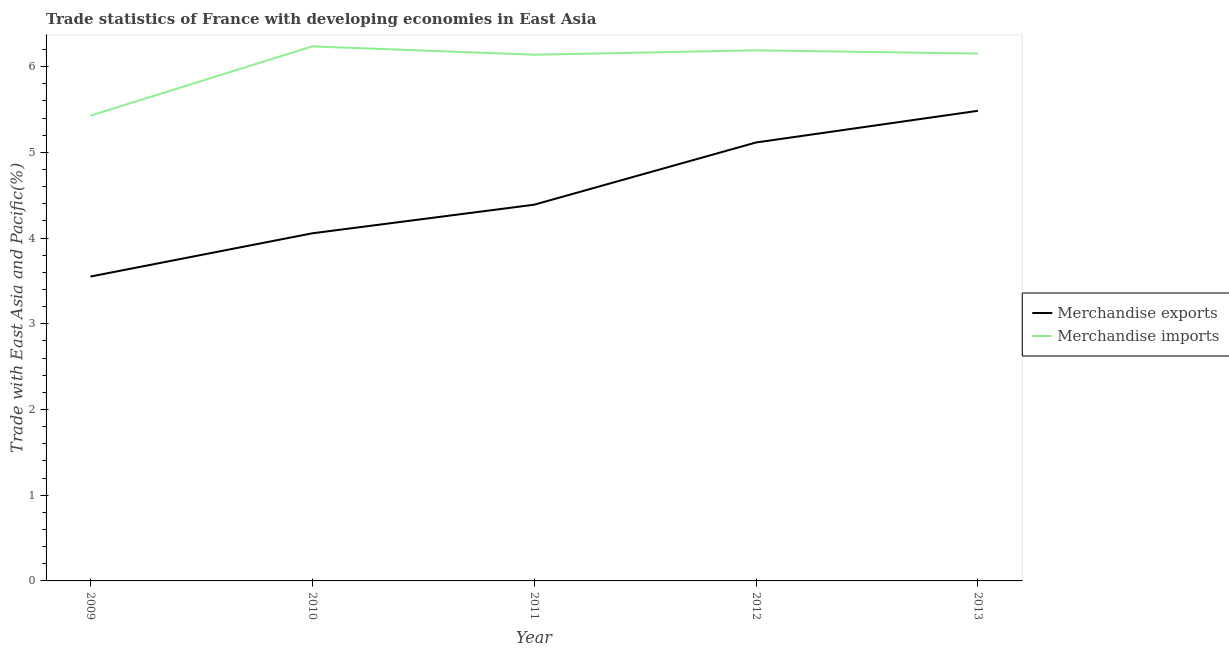How many different coloured lines are there?
Provide a succinct answer. 2. What is the merchandise imports in 2013?
Keep it short and to the point. 6.15. Across all years, what is the maximum merchandise imports?
Offer a very short reply. 6.24. Across all years, what is the minimum merchandise imports?
Make the answer very short. 5.43. In which year was the merchandise exports maximum?
Provide a succinct answer. 2013. In which year was the merchandise exports minimum?
Keep it short and to the point. 2009. What is the total merchandise exports in the graph?
Your answer should be compact. 22.6. What is the difference between the merchandise imports in 2011 and that in 2012?
Ensure brevity in your answer.  -0.05. What is the difference between the merchandise imports in 2013 and the merchandise exports in 2009?
Provide a succinct answer. 2.6. What is the average merchandise imports per year?
Offer a terse response. 6.03. In the year 2011, what is the difference between the merchandise imports and merchandise exports?
Provide a short and direct response. 1.75. In how many years, is the merchandise imports greater than 4.6 %?
Offer a very short reply. 5. What is the ratio of the merchandise exports in 2010 to that in 2013?
Provide a short and direct response. 0.74. What is the difference between the highest and the second highest merchandise imports?
Provide a succinct answer. 0.05. What is the difference between the highest and the lowest merchandise exports?
Your response must be concise. 1.93. Does the merchandise exports monotonically increase over the years?
Your answer should be very brief. Yes. Is the merchandise imports strictly less than the merchandise exports over the years?
Your answer should be very brief. No. How many lines are there?
Give a very brief answer. 2. How many years are there in the graph?
Provide a succinct answer. 5. What is the difference between two consecutive major ticks on the Y-axis?
Make the answer very short. 1. Are the values on the major ticks of Y-axis written in scientific E-notation?
Provide a succinct answer. No. Does the graph contain grids?
Your answer should be very brief. No. How are the legend labels stacked?
Ensure brevity in your answer.  Vertical. What is the title of the graph?
Your answer should be very brief. Trade statistics of France with developing economies in East Asia. What is the label or title of the Y-axis?
Your response must be concise. Trade with East Asia and Pacific(%). What is the Trade with East Asia and Pacific(%) of Merchandise exports in 2009?
Provide a short and direct response. 3.55. What is the Trade with East Asia and Pacific(%) of Merchandise imports in 2009?
Make the answer very short. 5.43. What is the Trade with East Asia and Pacific(%) of Merchandise exports in 2010?
Give a very brief answer. 4.06. What is the Trade with East Asia and Pacific(%) of Merchandise imports in 2010?
Your answer should be compact. 6.24. What is the Trade with East Asia and Pacific(%) in Merchandise exports in 2011?
Your answer should be very brief. 4.39. What is the Trade with East Asia and Pacific(%) in Merchandise imports in 2011?
Ensure brevity in your answer.  6.14. What is the Trade with East Asia and Pacific(%) of Merchandise exports in 2012?
Your answer should be very brief. 5.12. What is the Trade with East Asia and Pacific(%) of Merchandise imports in 2012?
Offer a very short reply. 6.19. What is the Trade with East Asia and Pacific(%) of Merchandise exports in 2013?
Keep it short and to the point. 5.48. What is the Trade with East Asia and Pacific(%) of Merchandise imports in 2013?
Make the answer very short. 6.15. Across all years, what is the maximum Trade with East Asia and Pacific(%) in Merchandise exports?
Keep it short and to the point. 5.48. Across all years, what is the maximum Trade with East Asia and Pacific(%) of Merchandise imports?
Provide a short and direct response. 6.24. Across all years, what is the minimum Trade with East Asia and Pacific(%) in Merchandise exports?
Ensure brevity in your answer.  3.55. Across all years, what is the minimum Trade with East Asia and Pacific(%) in Merchandise imports?
Ensure brevity in your answer.  5.43. What is the total Trade with East Asia and Pacific(%) in Merchandise exports in the graph?
Make the answer very short. 22.6. What is the total Trade with East Asia and Pacific(%) of Merchandise imports in the graph?
Your answer should be very brief. 30.15. What is the difference between the Trade with East Asia and Pacific(%) in Merchandise exports in 2009 and that in 2010?
Provide a succinct answer. -0.5. What is the difference between the Trade with East Asia and Pacific(%) in Merchandise imports in 2009 and that in 2010?
Make the answer very short. -0.81. What is the difference between the Trade with East Asia and Pacific(%) in Merchandise exports in 2009 and that in 2011?
Your answer should be very brief. -0.84. What is the difference between the Trade with East Asia and Pacific(%) of Merchandise imports in 2009 and that in 2011?
Your response must be concise. -0.71. What is the difference between the Trade with East Asia and Pacific(%) of Merchandise exports in 2009 and that in 2012?
Give a very brief answer. -1.56. What is the difference between the Trade with East Asia and Pacific(%) of Merchandise imports in 2009 and that in 2012?
Your answer should be very brief. -0.76. What is the difference between the Trade with East Asia and Pacific(%) of Merchandise exports in 2009 and that in 2013?
Ensure brevity in your answer.  -1.93. What is the difference between the Trade with East Asia and Pacific(%) of Merchandise imports in 2009 and that in 2013?
Ensure brevity in your answer.  -0.72. What is the difference between the Trade with East Asia and Pacific(%) in Merchandise exports in 2010 and that in 2011?
Ensure brevity in your answer.  -0.33. What is the difference between the Trade with East Asia and Pacific(%) of Merchandise imports in 2010 and that in 2011?
Give a very brief answer. 0.1. What is the difference between the Trade with East Asia and Pacific(%) of Merchandise exports in 2010 and that in 2012?
Your response must be concise. -1.06. What is the difference between the Trade with East Asia and Pacific(%) in Merchandise imports in 2010 and that in 2012?
Your answer should be very brief. 0.05. What is the difference between the Trade with East Asia and Pacific(%) of Merchandise exports in 2010 and that in 2013?
Provide a succinct answer. -1.43. What is the difference between the Trade with East Asia and Pacific(%) in Merchandise imports in 2010 and that in 2013?
Your answer should be very brief. 0.08. What is the difference between the Trade with East Asia and Pacific(%) in Merchandise exports in 2011 and that in 2012?
Your answer should be very brief. -0.73. What is the difference between the Trade with East Asia and Pacific(%) of Merchandise imports in 2011 and that in 2012?
Make the answer very short. -0.05. What is the difference between the Trade with East Asia and Pacific(%) in Merchandise exports in 2011 and that in 2013?
Give a very brief answer. -1.1. What is the difference between the Trade with East Asia and Pacific(%) in Merchandise imports in 2011 and that in 2013?
Your answer should be very brief. -0.01. What is the difference between the Trade with East Asia and Pacific(%) in Merchandise exports in 2012 and that in 2013?
Your answer should be compact. -0.37. What is the difference between the Trade with East Asia and Pacific(%) in Merchandise imports in 2012 and that in 2013?
Offer a terse response. 0.04. What is the difference between the Trade with East Asia and Pacific(%) in Merchandise exports in 2009 and the Trade with East Asia and Pacific(%) in Merchandise imports in 2010?
Offer a terse response. -2.69. What is the difference between the Trade with East Asia and Pacific(%) of Merchandise exports in 2009 and the Trade with East Asia and Pacific(%) of Merchandise imports in 2011?
Keep it short and to the point. -2.59. What is the difference between the Trade with East Asia and Pacific(%) in Merchandise exports in 2009 and the Trade with East Asia and Pacific(%) in Merchandise imports in 2012?
Offer a very short reply. -2.64. What is the difference between the Trade with East Asia and Pacific(%) in Merchandise exports in 2009 and the Trade with East Asia and Pacific(%) in Merchandise imports in 2013?
Your answer should be very brief. -2.6. What is the difference between the Trade with East Asia and Pacific(%) in Merchandise exports in 2010 and the Trade with East Asia and Pacific(%) in Merchandise imports in 2011?
Offer a very short reply. -2.08. What is the difference between the Trade with East Asia and Pacific(%) in Merchandise exports in 2010 and the Trade with East Asia and Pacific(%) in Merchandise imports in 2012?
Your answer should be compact. -2.13. What is the difference between the Trade with East Asia and Pacific(%) in Merchandise exports in 2010 and the Trade with East Asia and Pacific(%) in Merchandise imports in 2013?
Your response must be concise. -2.1. What is the difference between the Trade with East Asia and Pacific(%) in Merchandise exports in 2011 and the Trade with East Asia and Pacific(%) in Merchandise imports in 2012?
Your answer should be very brief. -1.8. What is the difference between the Trade with East Asia and Pacific(%) of Merchandise exports in 2011 and the Trade with East Asia and Pacific(%) of Merchandise imports in 2013?
Provide a short and direct response. -1.76. What is the difference between the Trade with East Asia and Pacific(%) in Merchandise exports in 2012 and the Trade with East Asia and Pacific(%) in Merchandise imports in 2013?
Your answer should be compact. -1.04. What is the average Trade with East Asia and Pacific(%) in Merchandise exports per year?
Give a very brief answer. 4.52. What is the average Trade with East Asia and Pacific(%) of Merchandise imports per year?
Your response must be concise. 6.03. In the year 2009, what is the difference between the Trade with East Asia and Pacific(%) of Merchandise exports and Trade with East Asia and Pacific(%) of Merchandise imports?
Ensure brevity in your answer.  -1.88. In the year 2010, what is the difference between the Trade with East Asia and Pacific(%) in Merchandise exports and Trade with East Asia and Pacific(%) in Merchandise imports?
Keep it short and to the point. -2.18. In the year 2011, what is the difference between the Trade with East Asia and Pacific(%) in Merchandise exports and Trade with East Asia and Pacific(%) in Merchandise imports?
Ensure brevity in your answer.  -1.75. In the year 2012, what is the difference between the Trade with East Asia and Pacific(%) of Merchandise exports and Trade with East Asia and Pacific(%) of Merchandise imports?
Your response must be concise. -1.07. In the year 2013, what is the difference between the Trade with East Asia and Pacific(%) of Merchandise exports and Trade with East Asia and Pacific(%) of Merchandise imports?
Keep it short and to the point. -0.67. What is the ratio of the Trade with East Asia and Pacific(%) of Merchandise exports in 2009 to that in 2010?
Provide a short and direct response. 0.88. What is the ratio of the Trade with East Asia and Pacific(%) of Merchandise imports in 2009 to that in 2010?
Give a very brief answer. 0.87. What is the ratio of the Trade with East Asia and Pacific(%) of Merchandise exports in 2009 to that in 2011?
Your answer should be compact. 0.81. What is the ratio of the Trade with East Asia and Pacific(%) in Merchandise imports in 2009 to that in 2011?
Offer a very short reply. 0.88. What is the ratio of the Trade with East Asia and Pacific(%) of Merchandise exports in 2009 to that in 2012?
Give a very brief answer. 0.69. What is the ratio of the Trade with East Asia and Pacific(%) in Merchandise imports in 2009 to that in 2012?
Ensure brevity in your answer.  0.88. What is the ratio of the Trade with East Asia and Pacific(%) of Merchandise exports in 2009 to that in 2013?
Your response must be concise. 0.65. What is the ratio of the Trade with East Asia and Pacific(%) of Merchandise imports in 2009 to that in 2013?
Offer a terse response. 0.88. What is the ratio of the Trade with East Asia and Pacific(%) of Merchandise exports in 2010 to that in 2011?
Your response must be concise. 0.92. What is the ratio of the Trade with East Asia and Pacific(%) of Merchandise imports in 2010 to that in 2011?
Offer a terse response. 1.02. What is the ratio of the Trade with East Asia and Pacific(%) of Merchandise exports in 2010 to that in 2012?
Provide a short and direct response. 0.79. What is the ratio of the Trade with East Asia and Pacific(%) of Merchandise imports in 2010 to that in 2012?
Make the answer very short. 1.01. What is the ratio of the Trade with East Asia and Pacific(%) of Merchandise exports in 2010 to that in 2013?
Offer a terse response. 0.74. What is the ratio of the Trade with East Asia and Pacific(%) of Merchandise imports in 2010 to that in 2013?
Offer a very short reply. 1.01. What is the ratio of the Trade with East Asia and Pacific(%) of Merchandise exports in 2011 to that in 2012?
Your answer should be very brief. 0.86. What is the ratio of the Trade with East Asia and Pacific(%) of Merchandise exports in 2011 to that in 2013?
Make the answer very short. 0.8. What is the ratio of the Trade with East Asia and Pacific(%) in Merchandise exports in 2012 to that in 2013?
Ensure brevity in your answer.  0.93. What is the difference between the highest and the second highest Trade with East Asia and Pacific(%) in Merchandise exports?
Your response must be concise. 0.37. What is the difference between the highest and the second highest Trade with East Asia and Pacific(%) of Merchandise imports?
Make the answer very short. 0.05. What is the difference between the highest and the lowest Trade with East Asia and Pacific(%) in Merchandise exports?
Provide a succinct answer. 1.93. What is the difference between the highest and the lowest Trade with East Asia and Pacific(%) in Merchandise imports?
Your answer should be compact. 0.81. 